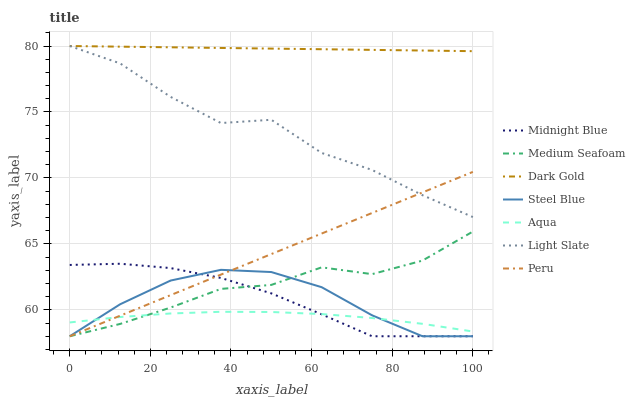Does Aqua have the minimum area under the curve?
Answer yes or no. Yes. Does Dark Gold have the maximum area under the curve?
Answer yes or no. Yes. Does Light Slate have the minimum area under the curve?
Answer yes or no. No. Does Light Slate have the maximum area under the curve?
Answer yes or no. No. Is Peru the smoothest?
Answer yes or no. Yes. Is Light Slate the roughest?
Answer yes or no. Yes. Is Dark Gold the smoothest?
Answer yes or no. No. Is Dark Gold the roughest?
Answer yes or no. No. Does Midnight Blue have the lowest value?
Answer yes or no. Yes. Does Light Slate have the lowest value?
Answer yes or no. No. Does Light Slate have the highest value?
Answer yes or no. Yes. Does Aqua have the highest value?
Answer yes or no. No. Is Steel Blue less than Dark Gold?
Answer yes or no. Yes. Is Dark Gold greater than Peru?
Answer yes or no. Yes. Does Peru intersect Midnight Blue?
Answer yes or no. Yes. Is Peru less than Midnight Blue?
Answer yes or no. No. Is Peru greater than Midnight Blue?
Answer yes or no. No. Does Steel Blue intersect Dark Gold?
Answer yes or no. No. 